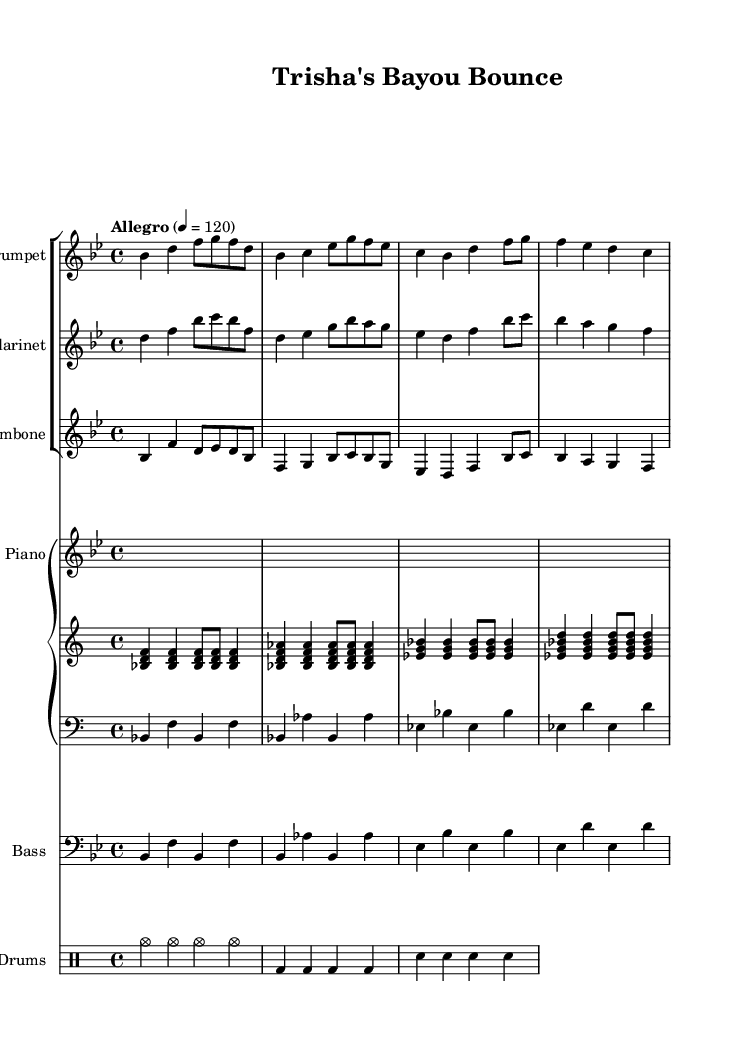What is the key signature of this music? The key signature is indicated by the number of sharps or flats at the beginning of the staff. In this piece, it shows two flats (B flat and E flat) which means it is in B flat major.
Answer: B flat major What is the time signature of this music? The time signature is found at the beginning of the piece and is represented by two numbers, with the top number indicating the number of beats per measure and the bottom indicating the note value that gets one beat. Here, it shows 4 over 4, meaning there are four beats per measure.
Answer: 4/4 What is the tempo marking for this piece? The tempo marking is indicated above the staff, specifying how fast the piece should be played. The marking "Allegro" indicates a fast tempo, and the number "4 = 120" indicates that the quarter note gets a beat of 120.
Answer: Allegro, 120 Which instrument plays the melody? To identify the instrument playing the melody, one looks at the highest line or part, which usually carries the primary melodic content. In this case, it's the trumpet part that plays higher notes and carries the melody line.
Answer: Trumpet What is the function of the drums in this piece? The drums, represented in a separate staff with specific notations for different elements (like cymbals, bass drum, and snare), provide the rhythmic foundation and accentuate the upbeat feel typical of jazz music. The drum patterns usually highlight the swing and groove of the ensemble.
Answer: Rhythmic foundation What type of jazz is this piece representing? This piece, with its ensemble of trumpet, clarinet, and trombone, along with a rhythm section, is characteristic of New Orleans-style jazz, which is known for its lively and celebratory spirit, suitable for honoring vibrant personalities like Trisha's on-screen charm.
Answer: New Orleans-style jazz What rhythmic style can be observed in the piano part? By analyzing the patterns in the piano part, we see syncopated rhythms that are common in jazz, where accented notes fall on unexpected beats, contributing to the lively and unique groove typical to this genre.
Answer: Syncopated rhythms 